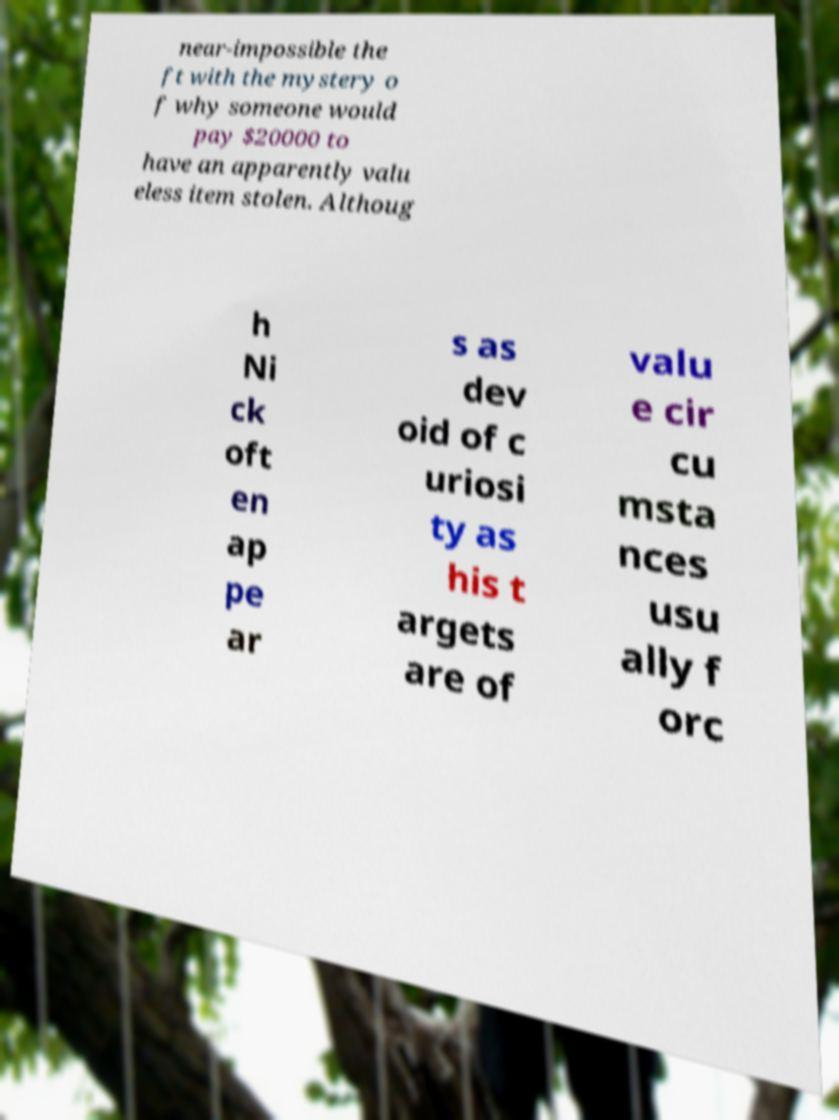Can you read and provide the text displayed in the image?This photo seems to have some interesting text. Can you extract and type it out for me? near-impossible the ft with the mystery o f why someone would pay $20000 to have an apparently valu eless item stolen. Althoug h Ni ck oft en ap pe ar s as dev oid of c uriosi ty as his t argets are of valu e cir cu msta nces usu ally f orc 